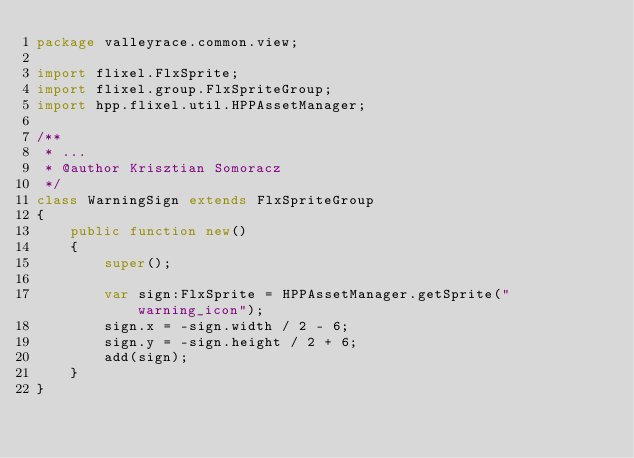<code> <loc_0><loc_0><loc_500><loc_500><_Haxe_>package valleyrace.common.view;

import flixel.FlxSprite;
import flixel.group.FlxSpriteGroup;
import hpp.flixel.util.HPPAssetManager;

/**
 * ...
 * @author Krisztian Somoracz
 */
class WarningSign extends FlxSpriteGroup
{
	public function new()
	{
		super();

		var sign:FlxSprite = HPPAssetManager.getSprite("warning_icon");
		sign.x = -sign.width / 2 - 6;
		sign.y = -sign.height / 2 + 6;
		add(sign);
	}
}</code> 